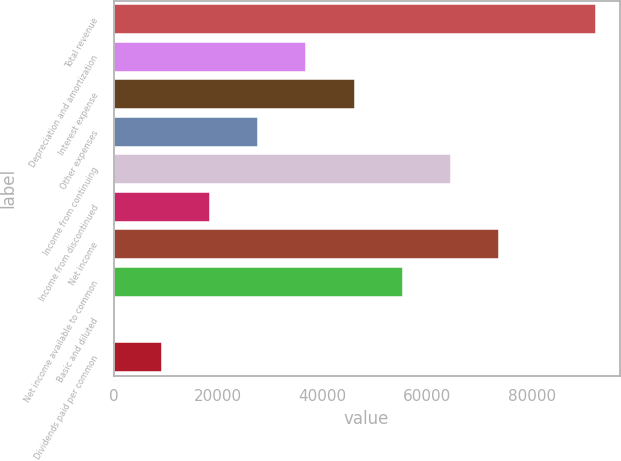Convert chart. <chart><loc_0><loc_0><loc_500><loc_500><bar_chart><fcel>Total revenue<fcel>Depreciation and amortization<fcel>Interest expense<fcel>Other expenses<fcel>Income from continuing<fcel>Income from discontinued<fcel>Net income<fcel>Net income available to common<fcel>Basic and diluted<fcel>Dividends paid per common<nl><fcel>92219<fcel>36887.8<fcel>46109.6<fcel>27665.9<fcel>64553.4<fcel>18444<fcel>73775.2<fcel>55331.5<fcel>0.28<fcel>9222.15<nl></chart> 